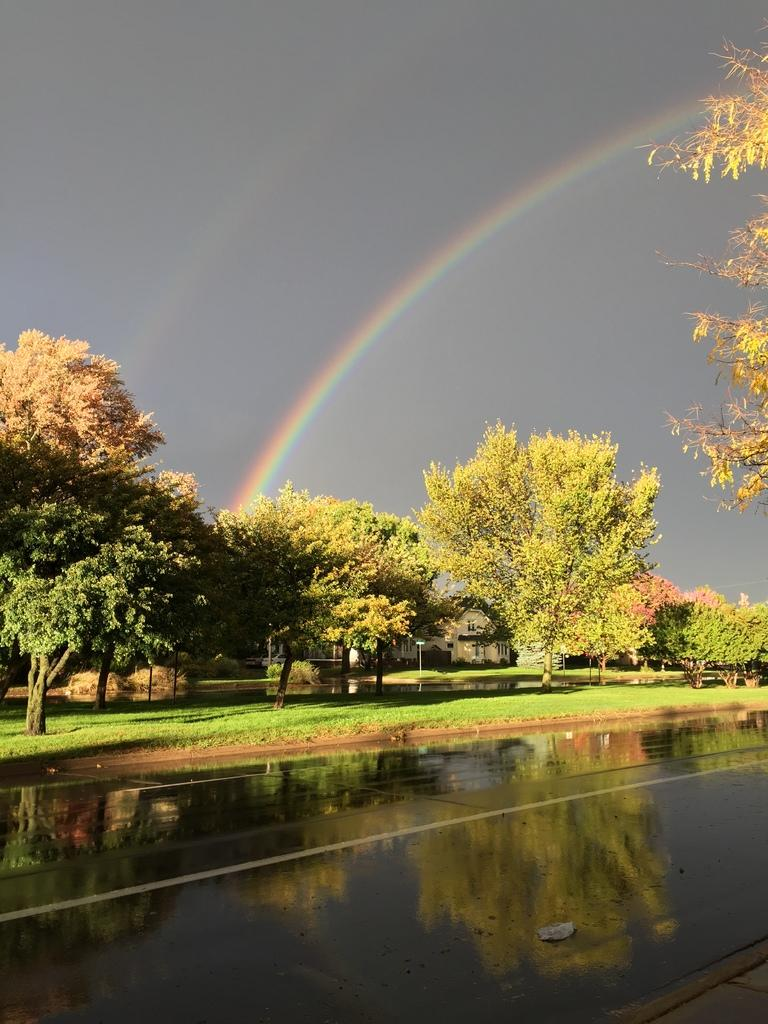What is the condition of the road in the image? The road is wet after raining. What type of vegetation is visible behind the road? There is grass behind the road. What can be seen growing on the grass? There are trees on the grass. What is visible in the sky in the image? There is a long rainbow in the sky. Can you see the group of people smiling on the wet road in the image? There is no group of people or any indication of smiling faces present in the image. 